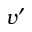Convert formula to latex. <formula><loc_0><loc_0><loc_500><loc_500>v ^ { \prime }</formula> 